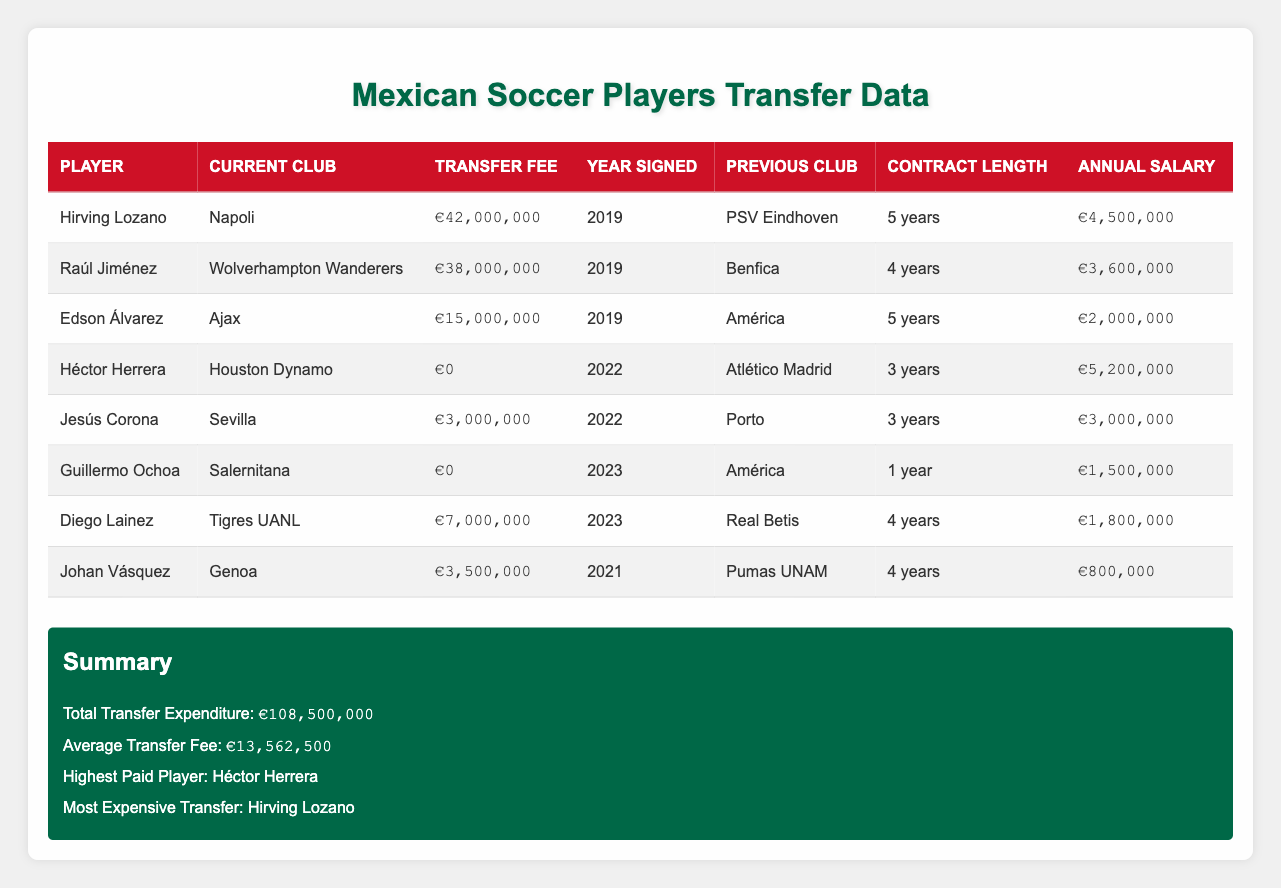What is the total transfer expenditure for Mexican national team members? The table summary states that the total transfer expenditure is €108,500,000, which is clearly marked in the summary section.
Answer: €108,500,000 Who is the highest paid player among the listed Mexican players? The summary section indicates that the highest paid player is Héctor Herrera.
Answer: Héctor Herrera What was the transfer fee for Edson Álvarez? In the table, Edson Álvarez is listed with a transfer fee of €15,000,000.
Answer: €15,000,000 How many players were signed in the year 2022? The table shows that there are two players signed in 2022: Héctor Herrera and Jesús Corona.
Answer: 2 What is the average annual salary of the players data presented? To calculate the average, we sum the annual salaries: €4,500,000 + €3,600,000 + €2,000,000 + €5,200,000 + €3,000,000 + €1,500,000 + €1,800,000 + €800,000 = €22,400,000. Then, divide by the number of players (8): €22,400,000 / 8 = €2,800,000.
Answer: €2,800,000 Is Hirving Lozano’s transfer fee higher than that of Edson Álvarez? Hirving Lozano has a transfer fee of €42,000,000, while Edson Álvarez has a fee of €15,000,000. Since 42,000,000 is greater than 15,000,000, the statement is true.
Answer: Yes What is the difference between the highest and lowest transfer fees? The highest transfer fee is Hirving Lozano's at €42,000,000, and the lowest transfer fee recorded (for Héctor Herrera and Guillermo Ochoa) is €0. The difference is calculated as 42,000,000 - 0 = €42,000,000.
Answer: €42,000,000 Are there any players who signed for a transfer fee of zero euros? Both Héctor Herrera and Guillermo Ochoa are listed with a transfer fee of €0. This confirms there are players with zero transfer fees.
Answer: Yes What is the combined transfer fee of the players signed in 2023? Both players signed in 2023 are Diego Lainez (€7,000,000) and Guillermo Ochoa (€0). Their combined transfer fee is €7,000,000 + €0 = €7,000,000.
Answer: €7,000,000 